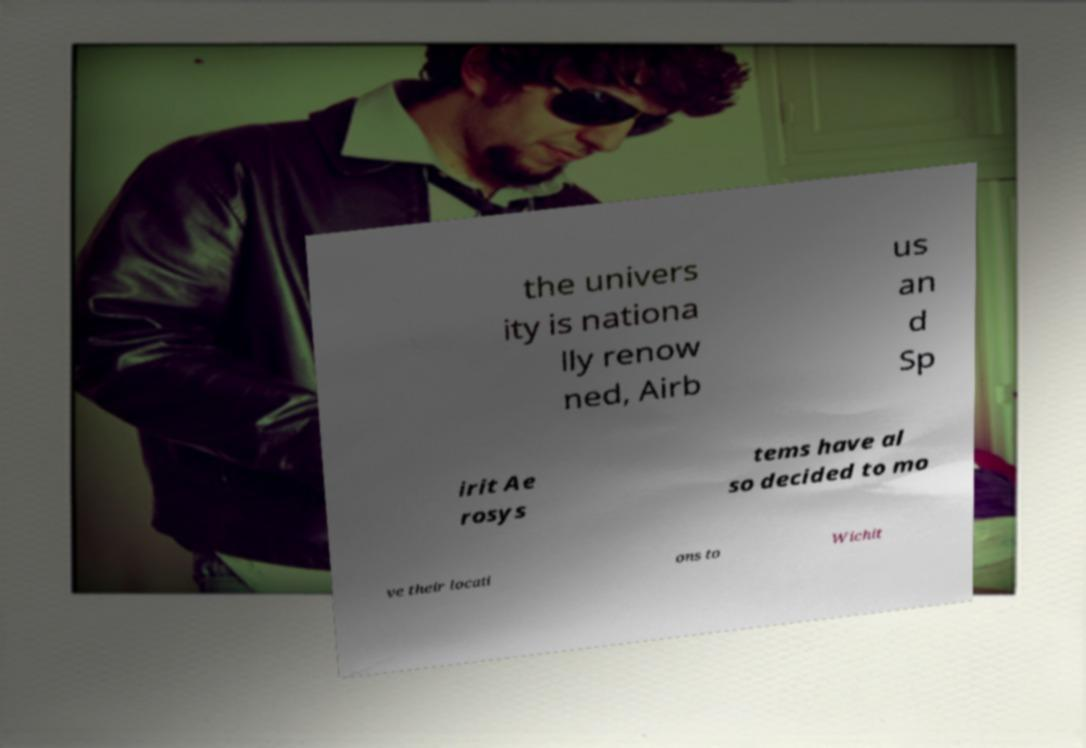Could you assist in decoding the text presented in this image and type it out clearly? the univers ity is nationa lly renow ned, Airb us an d Sp irit Ae rosys tems have al so decided to mo ve their locati ons to Wichit 